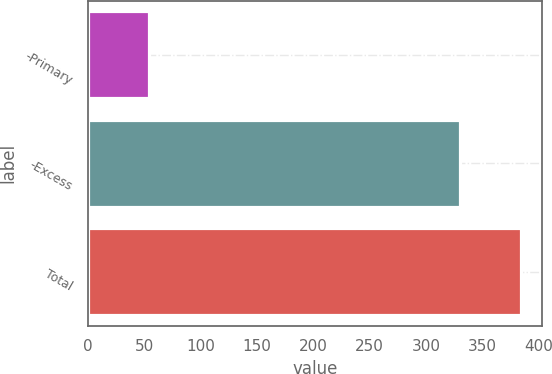<chart> <loc_0><loc_0><loc_500><loc_500><bar_chart><fcel>-Primary<fcel>-Excess<fcel>Total<nl><fcel>54<fcel>330<fcel>384<nl></chart> 